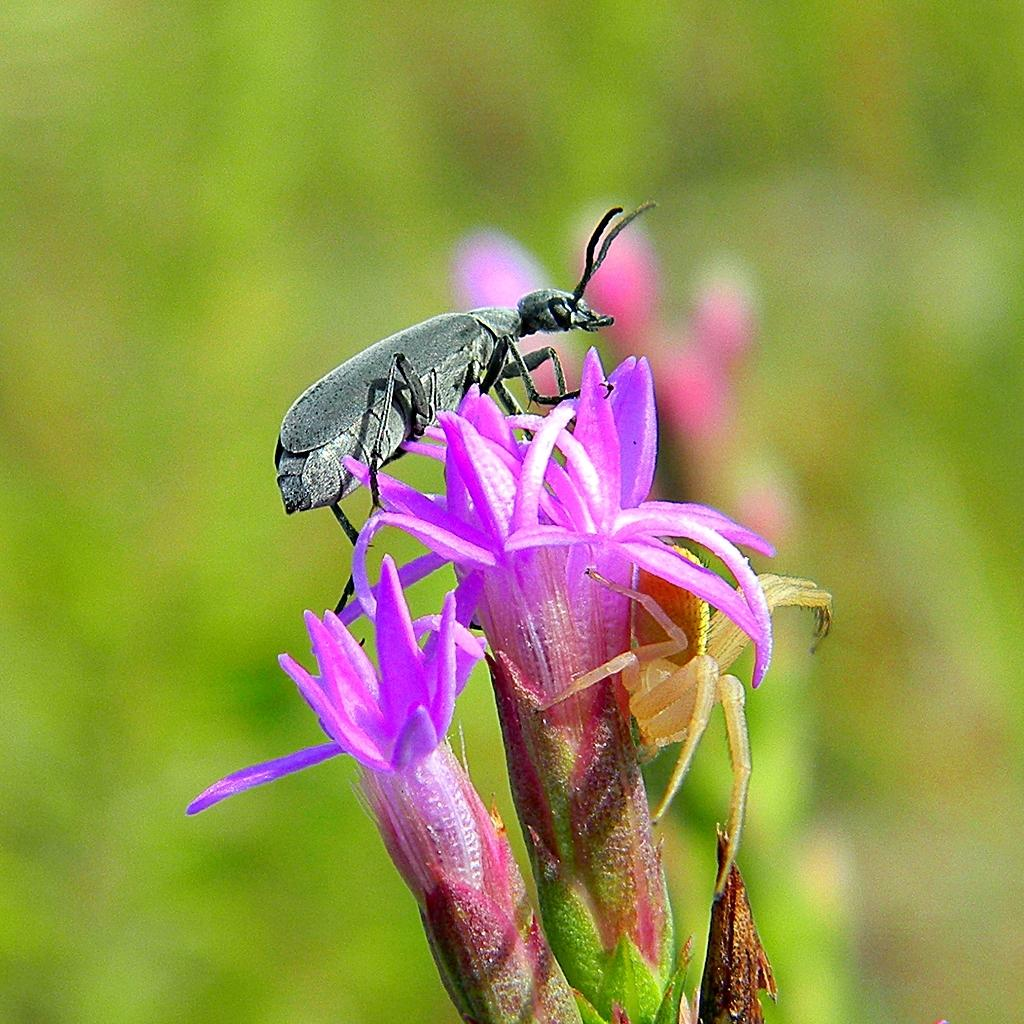How many flowers can be seen in the image? There are two flowers in the image. What color are the flowers? The flowers are purple. Is there any other living organism present on the flowers? Yes, there is an insect on one of the flowers. Are there any other flowers visible in the image? Yes, there is another flower visible behind the first two flowers. What can be seen in the background of the image? There are plants visible in the background, but they are not clearly visible. What type of writing can be seen on the representative's border in the image? There is no representative or border present in the image; it features flowers and an insect. 